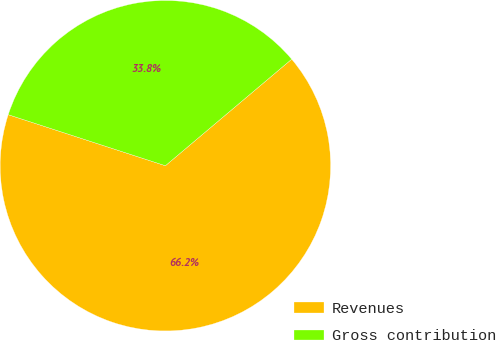<chart> <loc_0><loc_0><loc_500><loc_500><pie_chart><fcel>Revenues<fcel>Gross contribution<nl><fcel>66.15%<fcel>33.85%<nl></chart> 